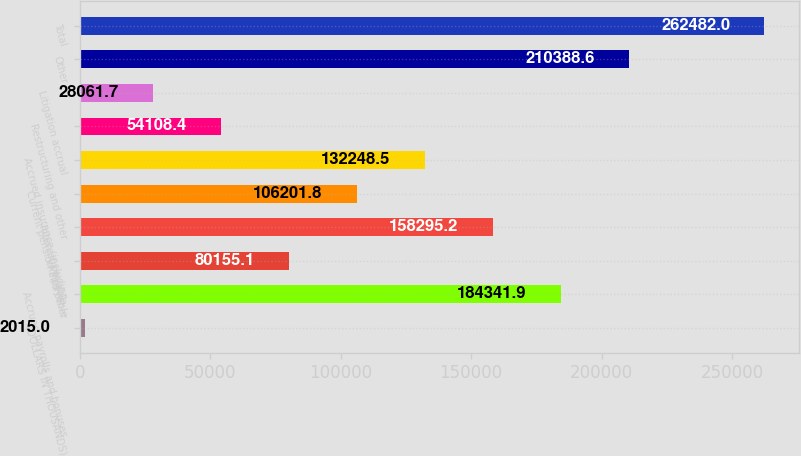Convert chart. <chart><loc_0><loc_0><loc_500><loc_500><bar_chart><fcel>(DOLLARS IN THOUSANDS)<fcel>Accrued payrolls and bonuses<fcel>VAT payable<fcel>Interest payable<fcel>Current pension and other<fcel>Accrued insurance (including<fcel>Restructuring and other<fcel>Litigation accrual<fcel>Other<fcel>Total<nl><fcel>2015<fcel>184342<fcel>80155.1<fcel>158295<fcel>106202<fcel>132248<fcel>54108.4<fcel>28061.7<fcel>210389<fcel>262482<nl></chart> 